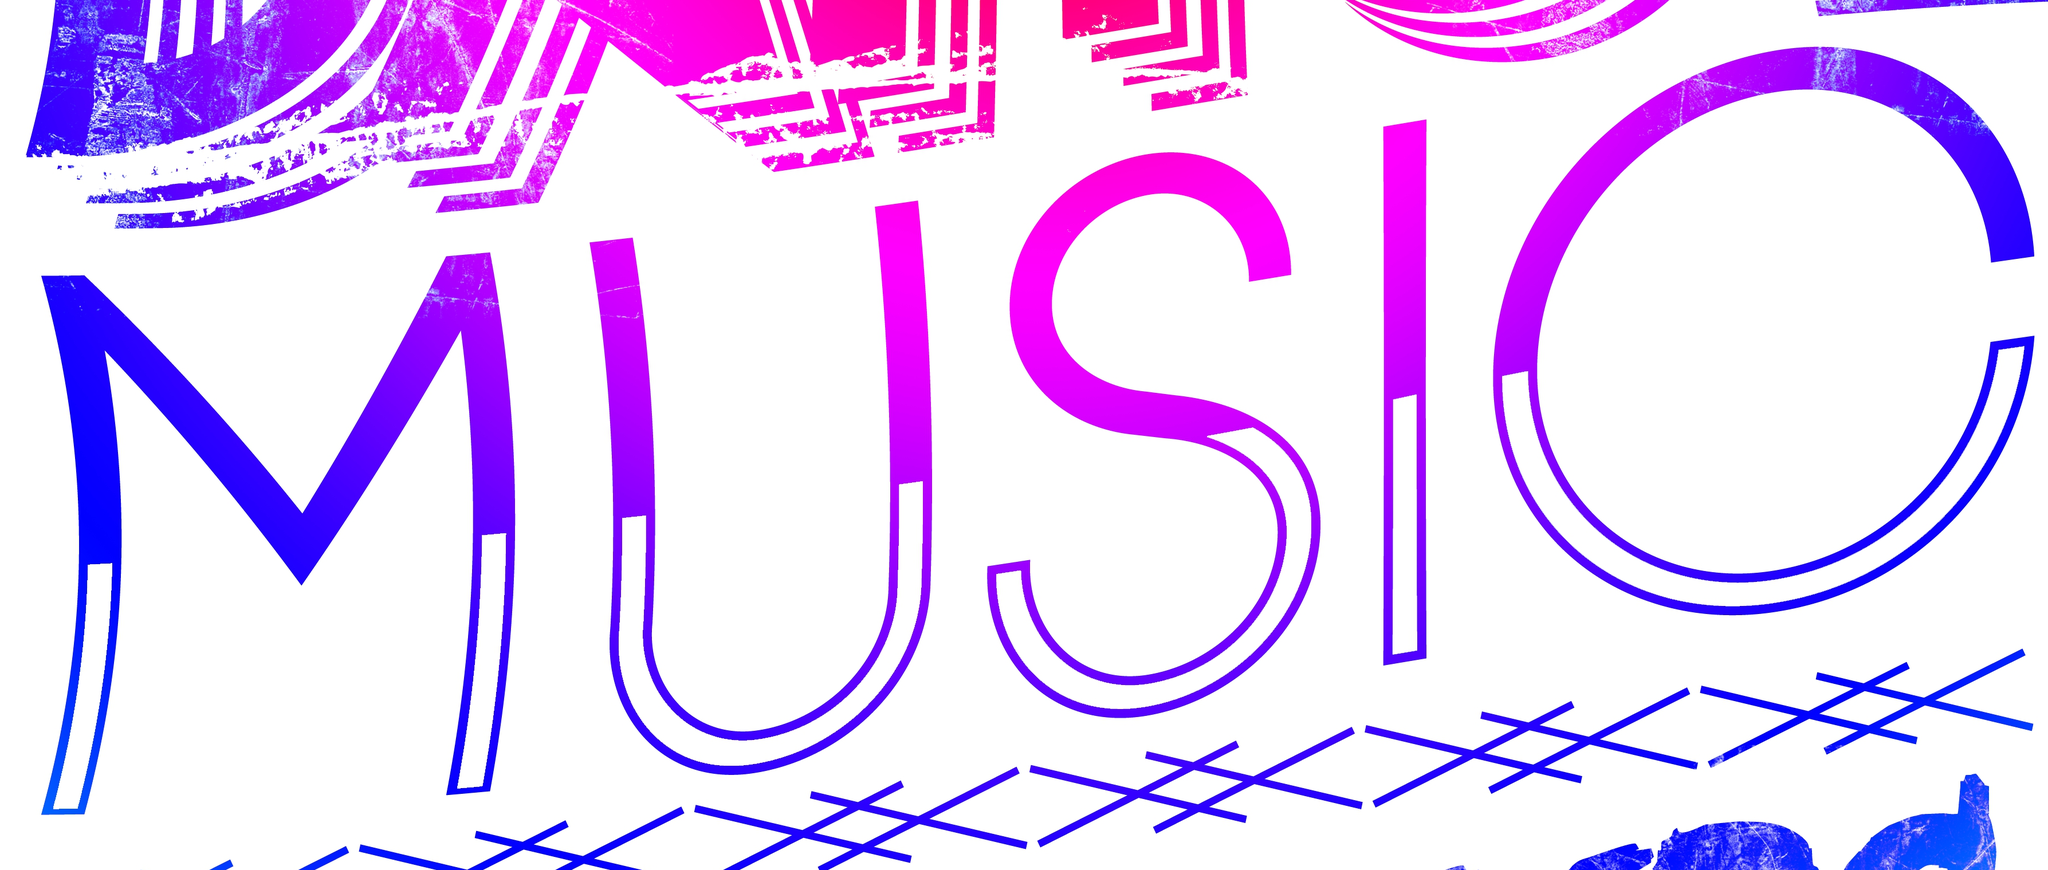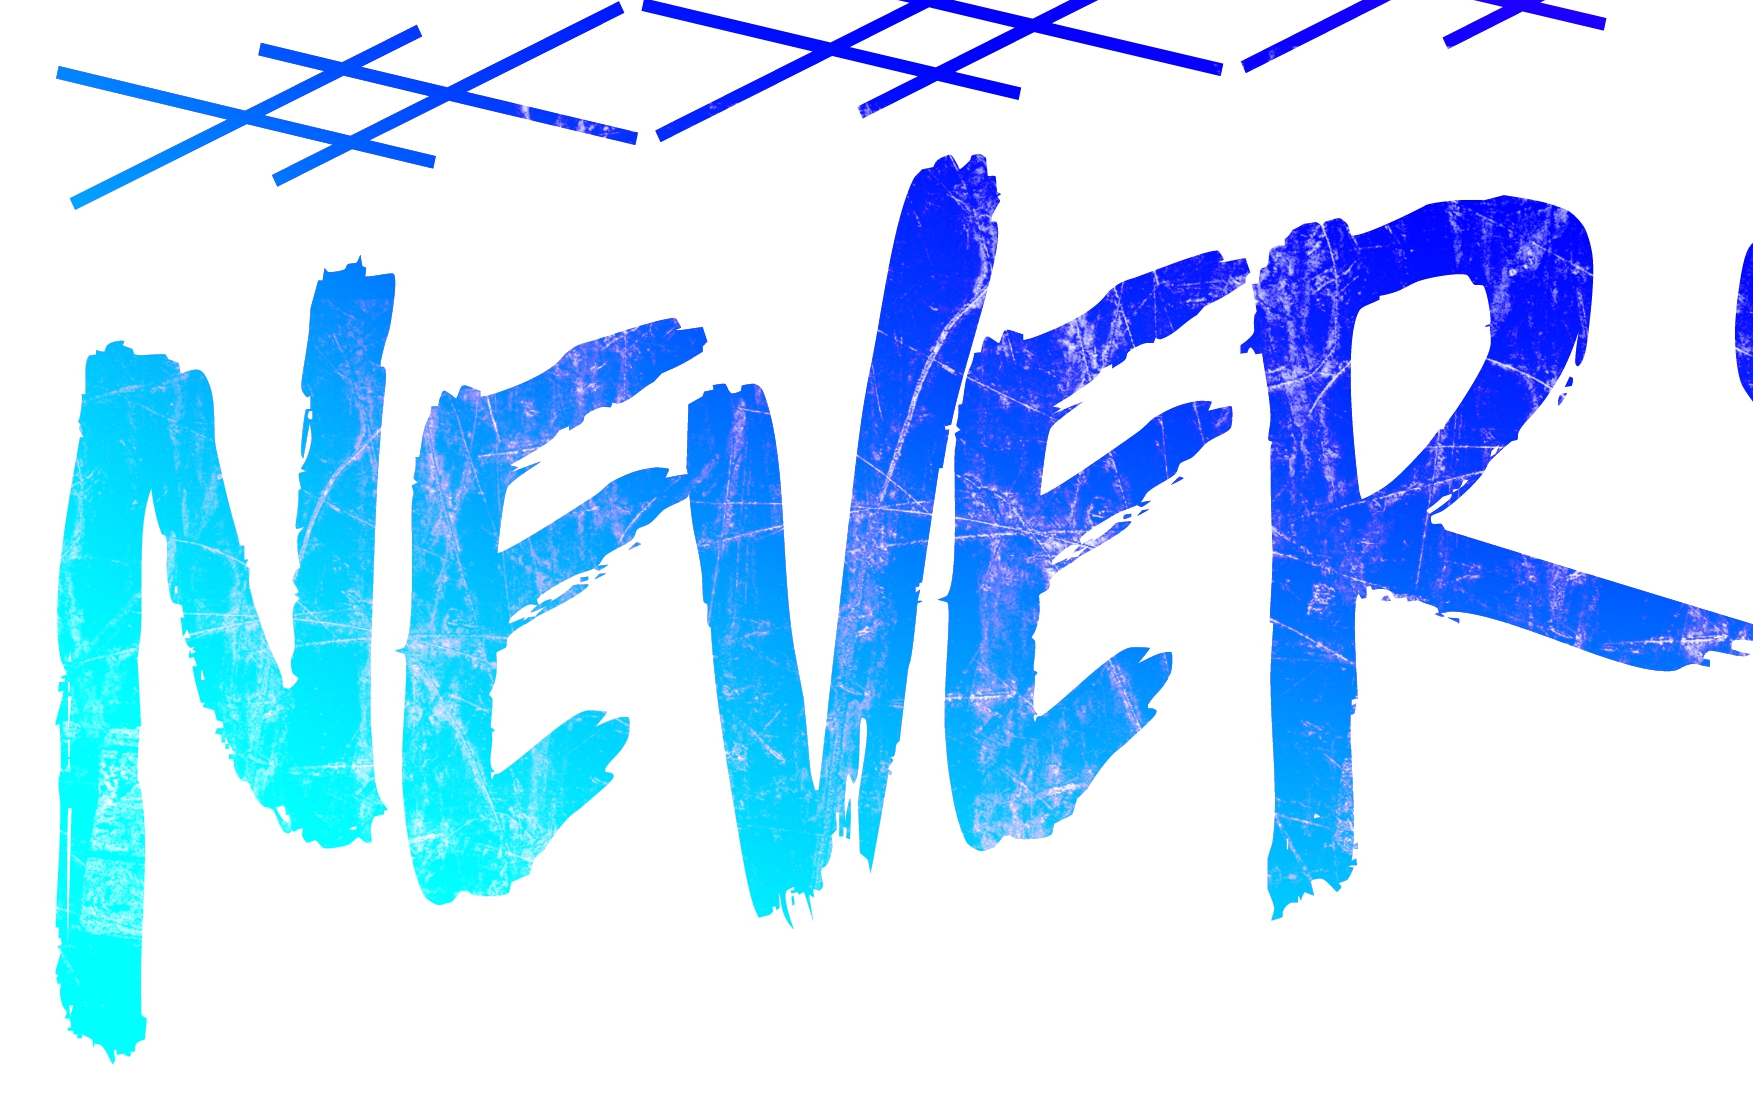What words are shown in these images in order, separated by a semicolon? MUSIC; NEVER 